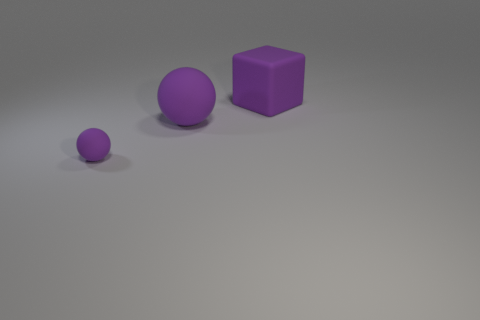Subtract all cubes. How many objects are left? 2 Subtract 1 cubes. How many cubes are left? 0 Add 1 purple rubber balls. How many objects exist? 4 Add 2 tiny purple things. How many tiny purple things are left? 3 Add 2 big spheres. How many big spheres exist? 3 Subtract 0 red cylinders. How many objects are left? 3 Subtract all brown spheres. Subtract all gray cylinders. How many spheres are left? 2 Subtract all brown cubes. How many cyan spheres are left? 0 Subtract all purple matte things. Subtract all tiny brown cubes. How many objects are left? 0 